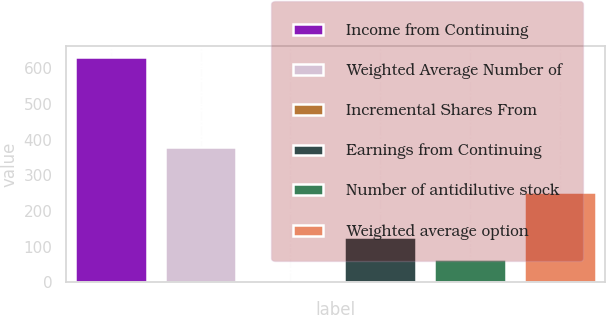<chart> <loc_0><loc_0><loc_500><loc_500><bar_chart><fcel>Income from Continuing<fcel>Weighted Average Number of<fcel>Incremental Shares From<fcel>Earnings from Continuing<fcel>Number of antidilutive stock<fcel>Weighted average option<nl><fcel>631<fcel>379.4<fcel>2<fcel>127.8<fcel>64.9<fcel>253.6<nl></chart> 